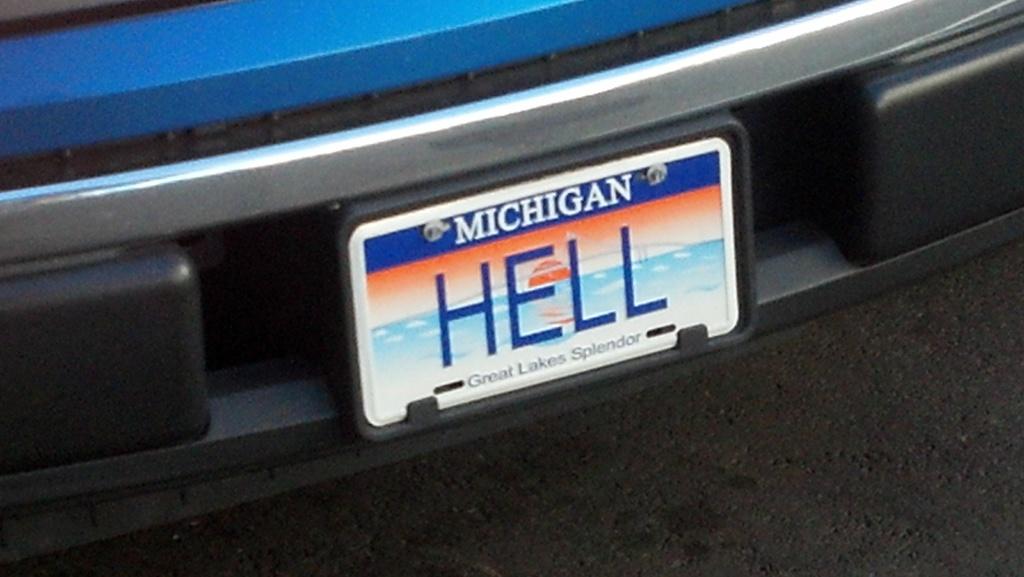What does the plate say?
Keep it short and to the point. Hell. 